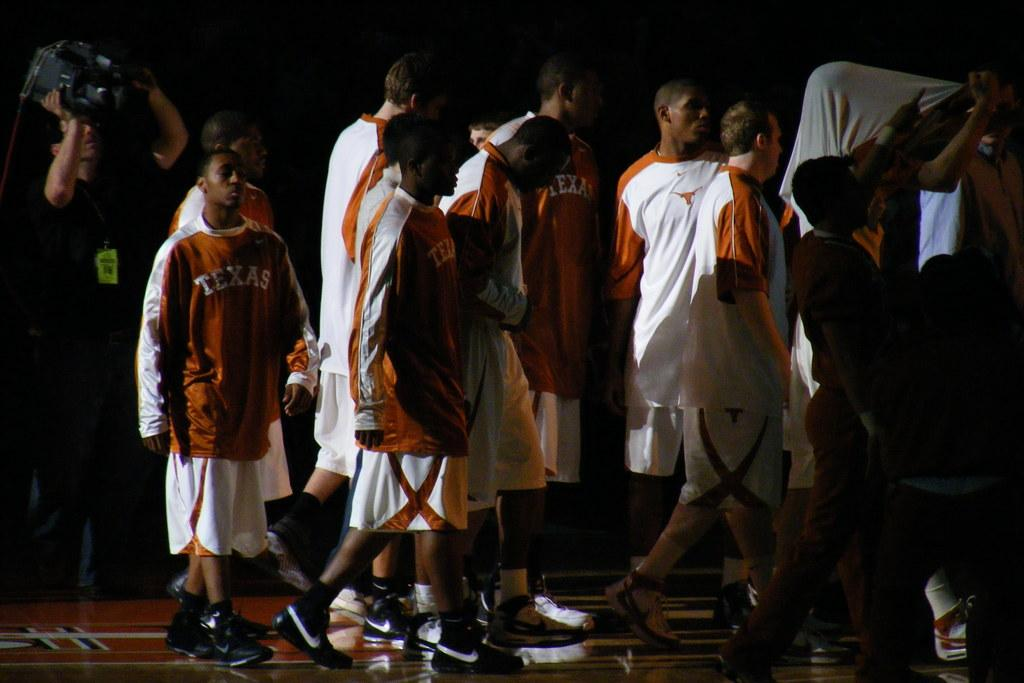How many people are in the image? There is a group of people in the image. What is the man on the left side doing? The man on the left side is holding a video camera. What can be observed about the lighting in the image? The background of the image is dark. Can you see any icicles hanging from the ship in the image? There is no ship or icicles present in the image. What is the group of people's reaction to the fear in the image? There is no fear or reaction to fear depicted in the image. 